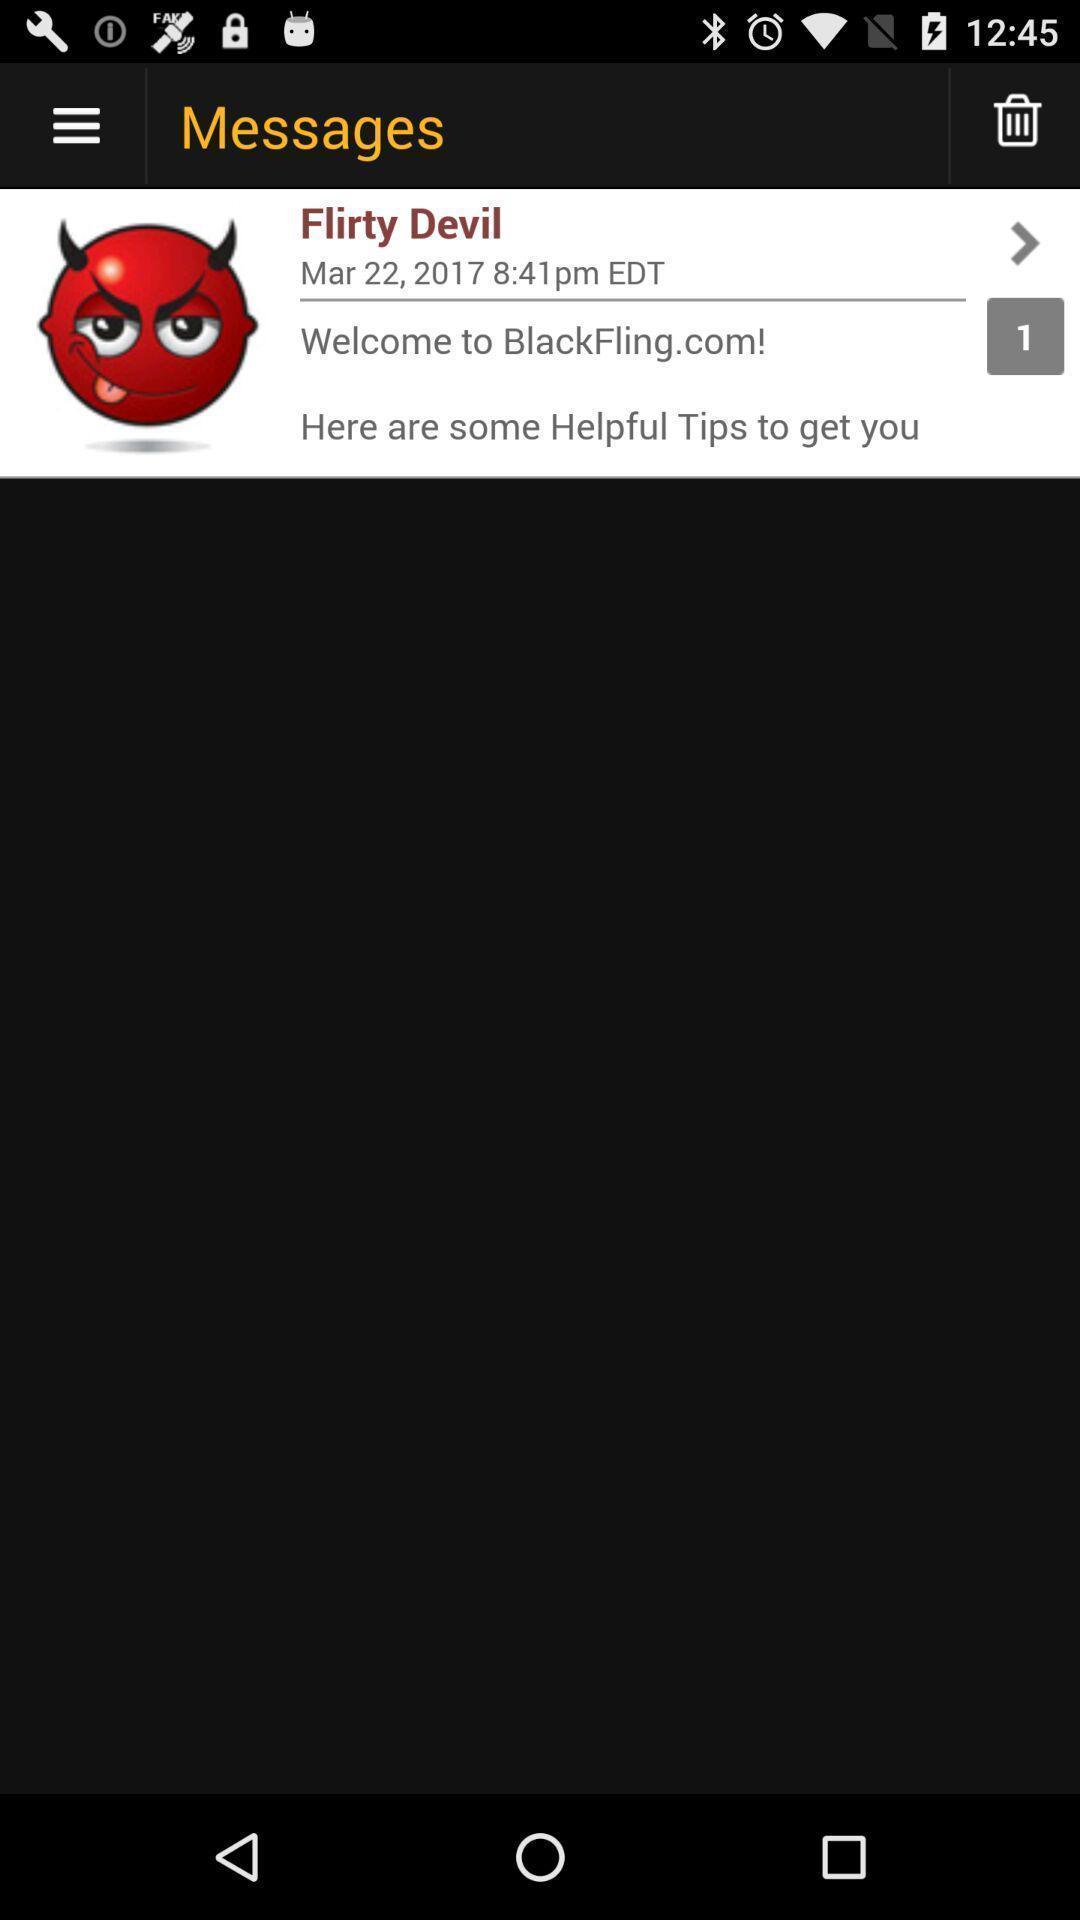Give me a narrative description of this picture. Page displaying with message list and details. 